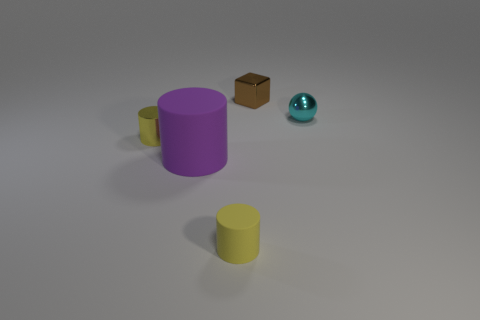Add 5 matte things. How many objects exist? 10 Subtract all cubes. How many objects are left? 4 Add 5 brown rubber spheres. How many brown rubber spheres exist? 5 Subtract 0 blue cubes. How many objects are left? 5 Subtract all small brown metallic blocks. Subtract all tiny shiny blocks. How many objects are left? 3 Add 5 yellow cylinders. How many yellow cylinders are left? 7 